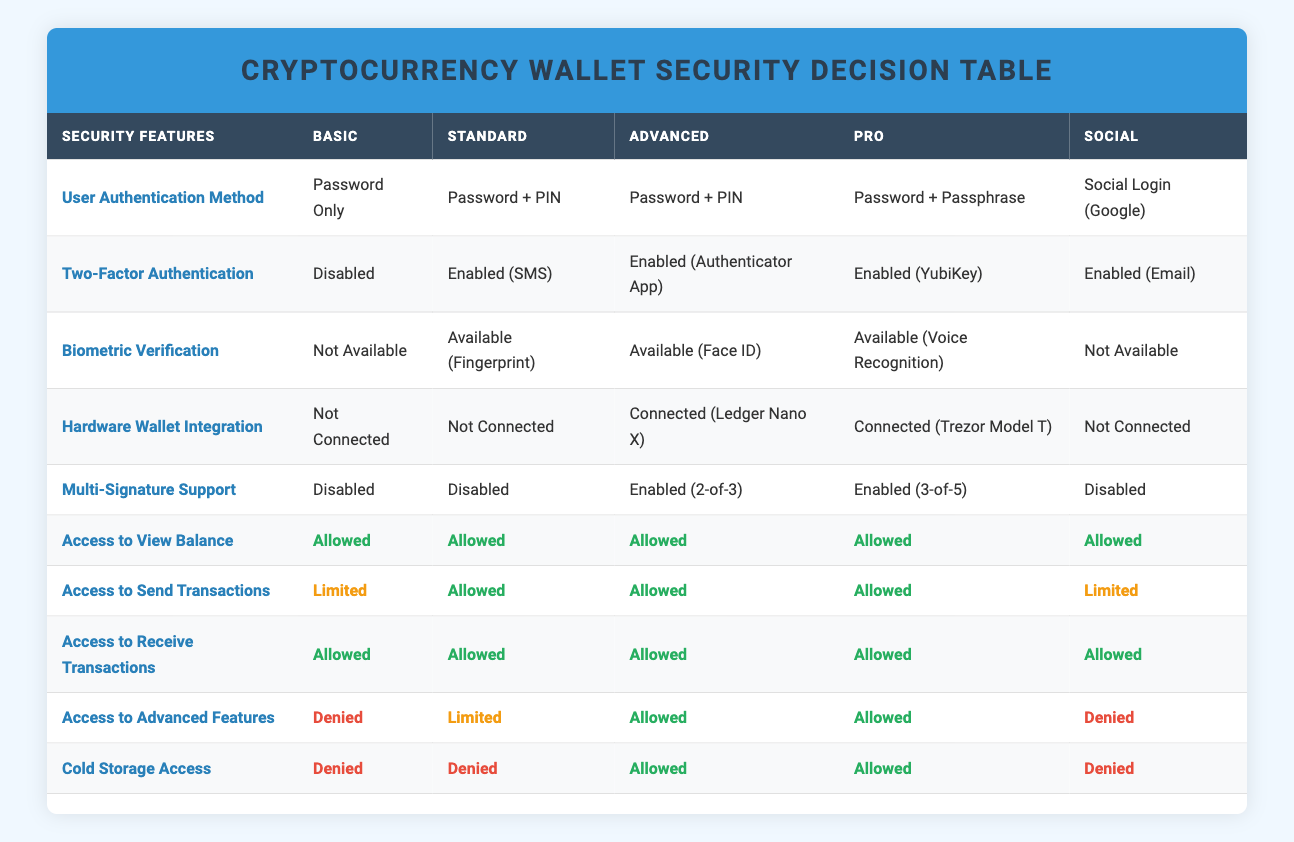What access do users have with the "Password + Passphrase" authentication method? Users with the "Password + Passphrase" authentication method can view balance, send transactions, receive transactions, access advanced features, and have cold storage access, as all these permissions are marked as "Allowed" in the respective row of the table.
Answer: Allowed for all features Is hardware wallet integration available for the "Social Login (Google)" method? For the "Social Login (Google)" method, the table indicates that hardware wallet integration is "Not Connected," meaning that this security feature is not available for this user authentication method.
Answer: No How many access features are denied for users with "Password Only"? Users with "Password Only" have "Access to Send Transactions" limited, while access to "Advanced Features" and "Cold Storage" is denied; thus, a total of 3 features are either limited or denied.
Answer: 3 features What is the difference in access to send transactions between "Password + PIN" with SMS and "Password + PIN" with an Authenticator App? Both "Password + PIN" setups allow sending transactions, but the former has "Limited" access while the latter has "Allowed" access, indicating that users with Authenticator App have more unrestricted access. Therefore, the difference in access is that one is limited while the other is allowed.
Answer: One is limited, the other is allowed Do users utilizing "Multi-Signature Support" have different levels of cold storage access? Examining the "Multi-Signature Support" rows in the table, users with "Enabled (3-of-5)" and "Enabled (2-of-3)" have "Allowed" access to cold storage, while others either have "Denied" access or no multi-signature support, indicating they have similar cold storage access levels.
Answer: No, they both have allowed access 